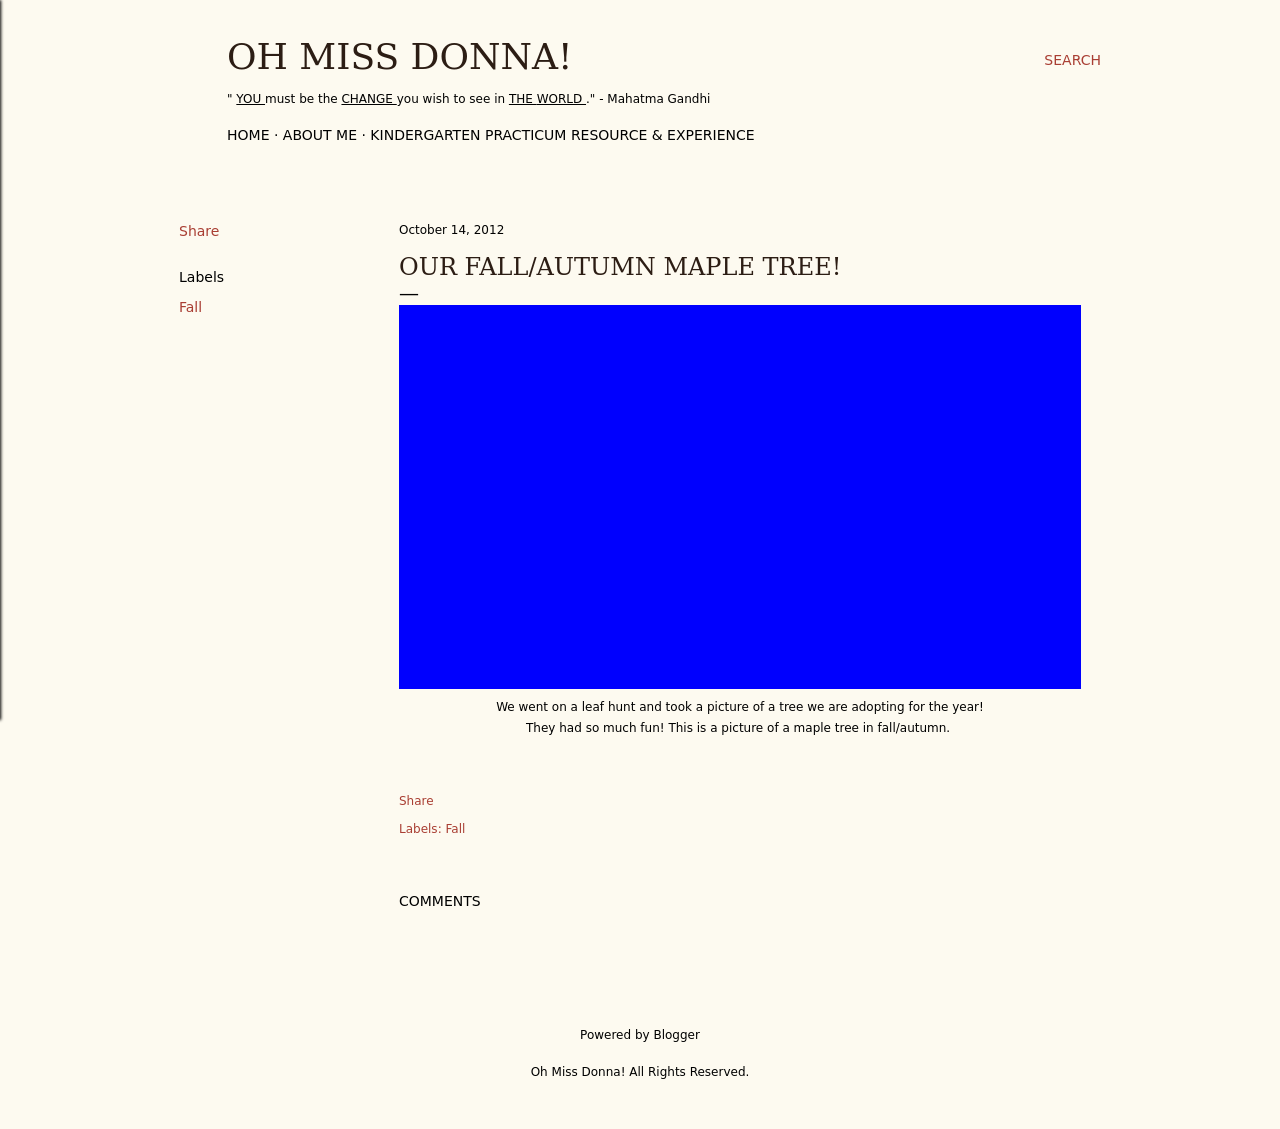What's the procedure for constructing this website from scratch with HTML? To construct a website from scratch similar to the one depicted in the image, which features a post about an autumn/fall maple tree, you would start by creating a basic HTML structure. This would include HTML tags for setting up the page, a header section for the title, navigation links, and blog posts. CSS would be used for styling the page to capture the aesthetic of fall, such as warm colors, while JavaScript could be applied for interactive elements, like a gallery of changing leaves or interactive posts about different types of trees. The focus would be on simplicity and reflecting the natural beauty of fall. 